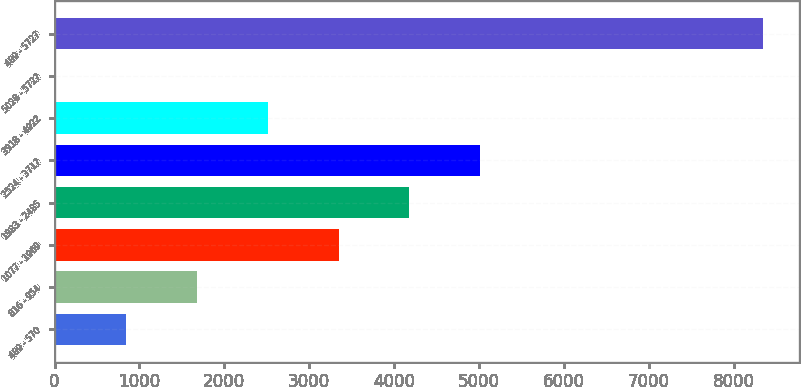Convert chart. <chart><loc_0><loc_0><loc_500><loc_500><bar_chart><fcel>489 - 570<fcel>816 - 954<fcel>1077 - 1969<fcel>1983 - 2485<fcel>2524 - 3717<fcel>3918 - 4922<fcel>5028 - 5727<fcel>489 - 5727<nl><fcel>844.1<fcel>1678.2<fcel>3346.4<fcel>4180.5<fcel>5014.6<fcel>2512.3<fcel>10<fcel>8351<nl></chart> 